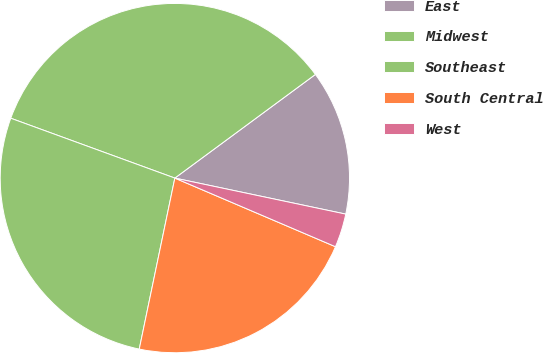Convert chart to OTSL. <chart><loc_0><loc_0><loc_500><loc_500><pie_chart><fcel>East<fcel>Midwest<fcel>Southeast<fcel>South Central<fcel>West<nl><fcel>13.42%<fcel>34.32%<fcel>27.3%<fcel>21.84%<fcel>3.12%<nl></chart> 